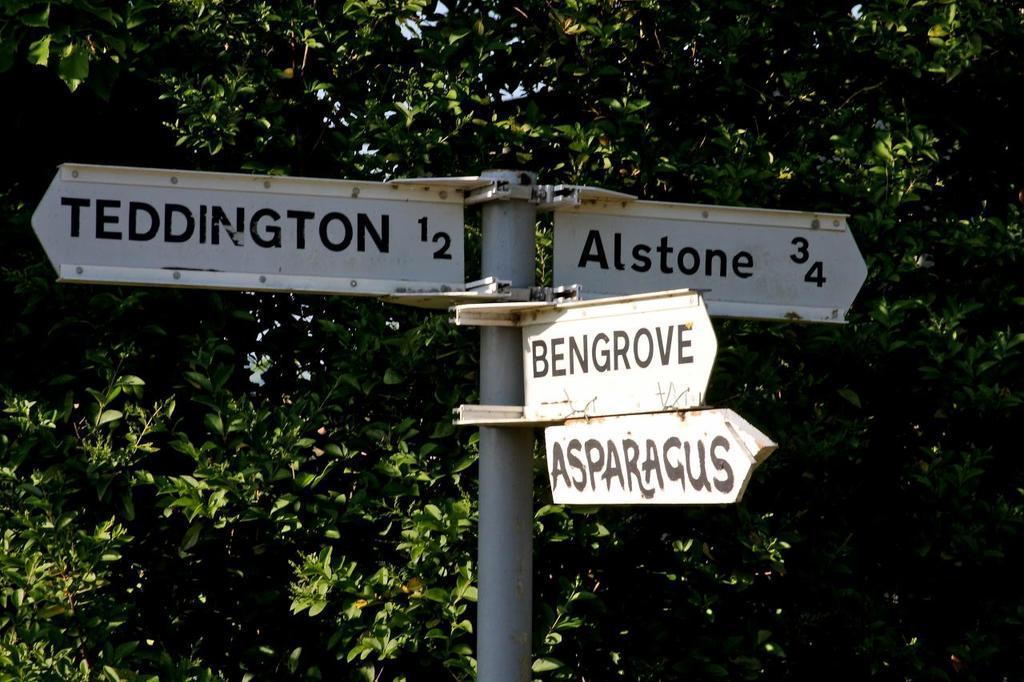In one or two sentences, can you explain what this image depicts? In this picture I can see the boards fixed to the pole. I can see trees in the background. 